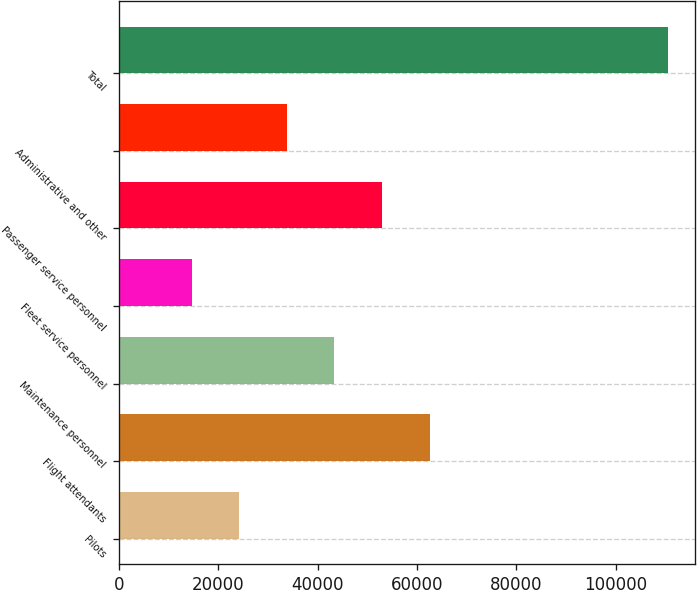Convert chart to OTSL. <chart><loc_0><loc_0><loc_500><loc_500><bar_chart><fcel>Pilots<fcel>Flight attendants<fcel>Maintenance personnel<fcel>Fleet service personnel<fcel>Passenger service personnel<fcel>Administrative and other<fcel>Total<nl><fcel>24180<fcel>62500<fcel>43340<fcel>14600<fcel>52920<fcel>33760<fcel>110400<nl></chart> 